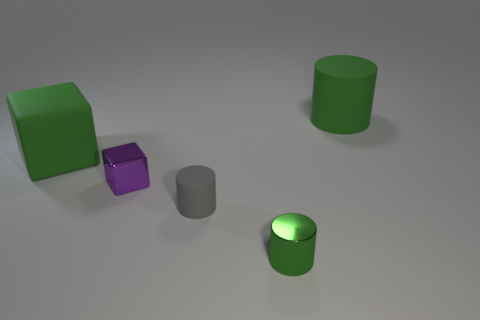Is the shape of the big thing on the right side of the shiny cylinder the same as  the gray rubber thing?
Your response must be concise. Yes. There is a tiny cylinder that is behind the green cylinder that is in front of the tiny rubber object; what number of green matte things are in front of it?
Give a very brief answer. 0. Are there fewer gray objects right of the gray cylinder than small green shiny cylinders that are left of the tiny purple block?
Provide a short and direct response. No. The other tiny object that is the same shape as the small matte thing is what color?
Your answer should be compact. Green. The gray thing has what size?
Offer a terse response. Small. What number of matte objects are the same size as the green cube?
Your answer should be compact. 1. Is the color of the small matte cylinder the same as the big matte cylinder?
Your response must be concise. No. Is the big thing on the right side of the tiny gray matte cylinder made of the same material as the big green object to the left of the large green cylinder?
Provide a short and direct response. Yes. Is the number of matte spheres greater than the number of tiny gray rubber objects?
Your answer should be very brief. No. Is there any other thing that is the same color as the big block?
Offer a very short reply. Yes. 